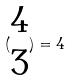<formula> <loc_0><loc_0><loc_500><loc_500>( \begin{matrix} 4 \\ 3 \end{matrix} ) = 4</formula> 